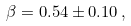<formula> <loc_0><loc_0><loc_500><loc_500>\beta = 0 . 5 4 \pm 0 . 1 0 \, , \,</formula> 